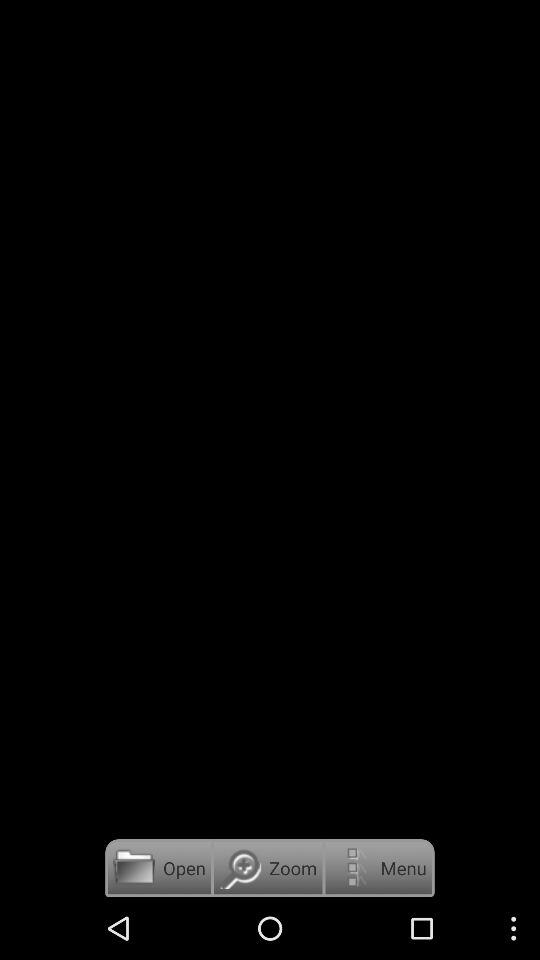How many options are there for downloading the song book?
Answer the question using a single word or phrase. 3 